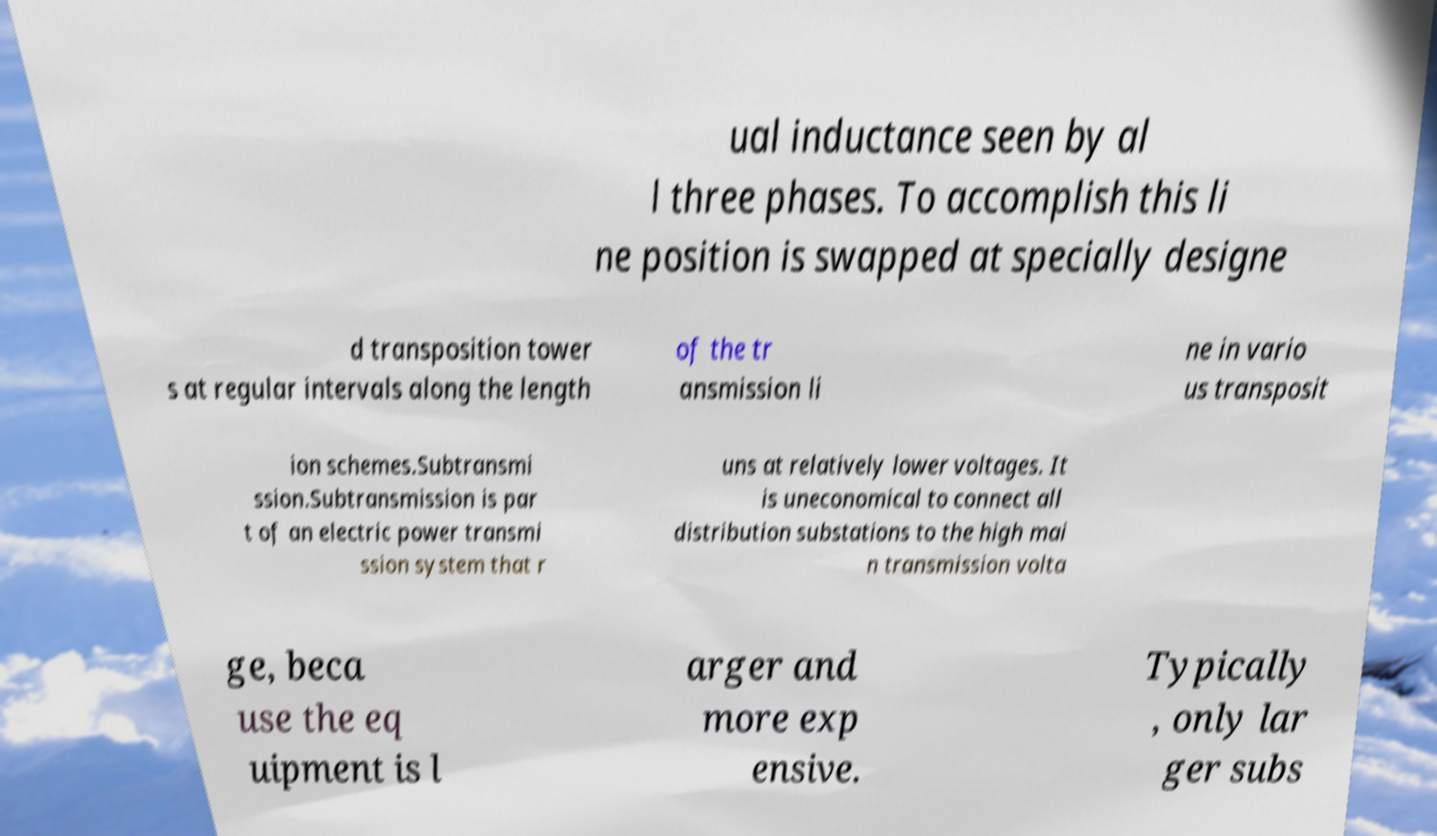Please read and relay the text visible in this image. What does it say? ual inductance seen by al l three phases. To accomplish this li ne position is swapped at specially designe d transposition tower s at regular intervals along the length of the tr ansmission li ne in vario us transposit ion schemes.Subtransmi ssion.Subtransmission is par t of an electric power transmi ssion system that r uns at relatively lower voltages. It is uneconomical to connect all distribution substations to the high mai n transmission volta ge, beca use the eq uipment is l arger and more exp ensive. Typically , only lar ger subs 